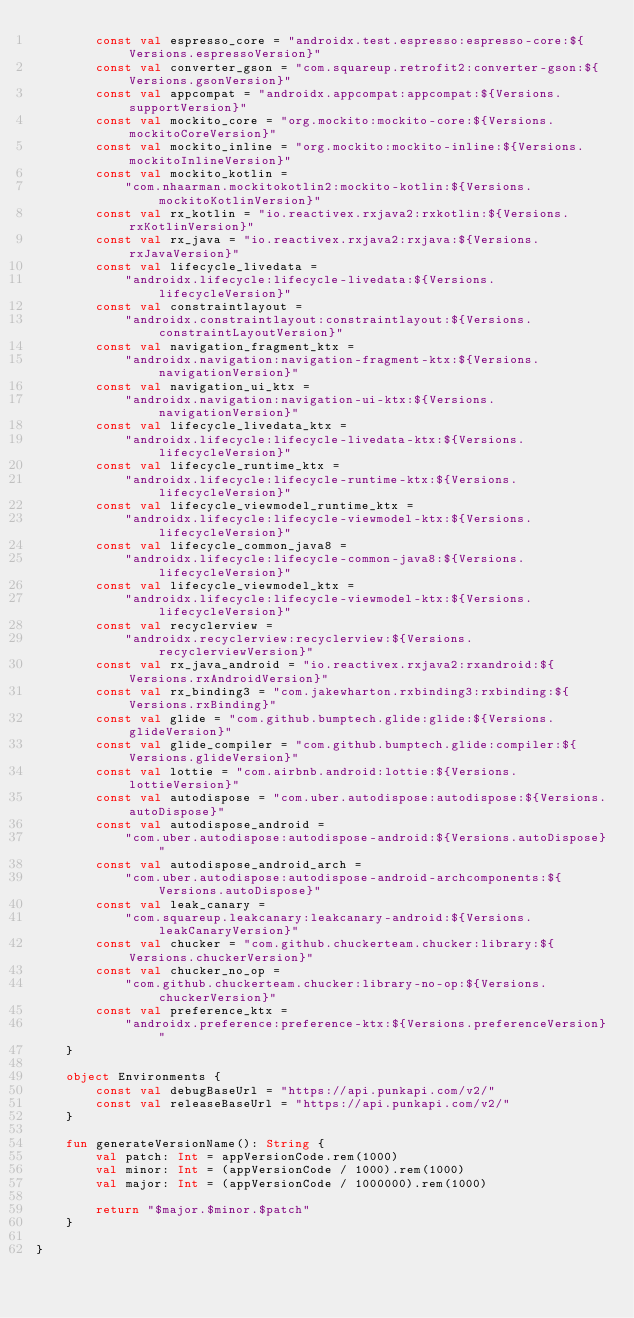Convert code to text. <code><loc_0><loc_0><loc_500><loc_500><_Kotlin_>        const val espresso_core = "androidx.test.espresso:espresso-core:${Versions.espressoVersion}"
        const val converter_gson = "com.squareup.retrofit2:converter-gson:${Versions.gsonVersion}"
        const val appcompat = "androidx.appcompat:appcompat:${Versions.supportVersion}"
        const val mockito_core = "org.mockito:mockito-core:${Versions.mockitoCoreVersion}"
        const val mockito_inline = "org.mockito:mockito-inline:${Versions.mockitoInlineVersion}"
        const val mockito_kotlin =
            "com.nhaarman.mockitokotlin2:mockito-kotlin:${Versions.mockitoKotlinVersion}"
        const val rx_kotlin = "io.reactivex.rxjava2:rxkotlin:${Versions.rxKotlinVersion}"
        const val rx_java = "io.reactivex.rxjava2:rxjava:${Versions.rxJavaVersion}"
        const val lifecycle_livedata =
            "androidx.lifecycle:lifecycle-livedata:${Versions.lifecycleVersion}"
        const val constraintlayout =
            "androidx.constraintlayout:constraintlayout:${Versions.constraintLayoutVersion}"
        const val navigation_fragment_ktx =
            "androidx.navigation:navigation-fragment-ktx:${Versions.navigationVersion}"
        const val navigation_ui_ktx =
            "androidx.navigation:navigation-ui-ktx:${Versions.navigationVersion}"
        const val lifecycle_livedata_ktx =
            "androidx.lifecycle:lifecycle-livedata-ktx:${Versions.lifecycleVersion}"
        const val lifecycle_runtime_ktx =
            "androidx.lifecycle:lifecycle-runtime-ktx:${Versions.lifecycleVersion}"
        const val lifecycle_viewmodel_runtime_ktx =
            "androidx.lifecycle:lifecycle-viewmodel-ktx:${Versions.lifecycleVersion}"
        const val lifecycle_common_java8 =
            "androidx.lifecycle:lifecycle-common-java8:${Versions.lifecycleVersion}"
        const val lifecycle_viewmodel_ktx =
            "androidx.lifecycle:lifecycle-viewmodel-ktx:${Versions.lifecycleVersion}"
        const val recyclerview =
            "androidx.recyclerview:recyclerview:${Versions.recyclerviewVersion}"
        const val rx_java_android = "io.reactivex.rxjava2:rxandroid:${Versions.rxAndroidVersion}"
        const val rx_binding3 = "com.jakewharton.rxbinding3:rxbinding:${Versions.rxBinding}"
        const val glide = "com.github.bumptech.glide:glide:${Versions.glideVersion}"
        const val glide_compiler = "com.github.bumptech.glide:compiler:${Versions.glideVersion}"
        const val lottie = "com.airbnb.android:lottie:${Versions.lottieVersion}"
        const val autodispose = "com.uber.autodispose:autodispose:${Versions.autoDispose}"
        const val autodispose_android =
            "com.uber.autodispose:autodispose-android:${Versions.autoDispose}"
        const val autodispose_android_arch =
            "com.uber.autodispose:autodispose-android-archcomponents:${Versions.autoDispose}"
        const val leak_canary =
            "com.squareup.leakcanary:leakcanary-android:${Versions.leakCanaryVersion}"
        const val chucker = "com.github.chuckerteam.chucker:library:${Versions.chuckerVersion}"
        const val chucker_no_op =
            "com.github.chuckerteam.chucker:library-no-op:${Versions.chuckerVersion}"
        const val preference_ktx =
            "androidx.preference:preference-ktx:${Versions.preferenceVersion}"
    }

    object Environments {
        const val debugBaseUrl = "https://api.punkapi.com/v2/"
        const val releaseBaseUrl = "https://api.punkapi.com/v2/"
    }

    fun generateVersionName(): String {
        val patch: Int = appVersionCode.rem(1000)
        val minor: Int = (appVersionCode / 1000).rem(1000)
        val major: Int = (appVersionCode / 1000000).rem(1000)

        return "$major.$minor.$patch"
    }

}</code> 